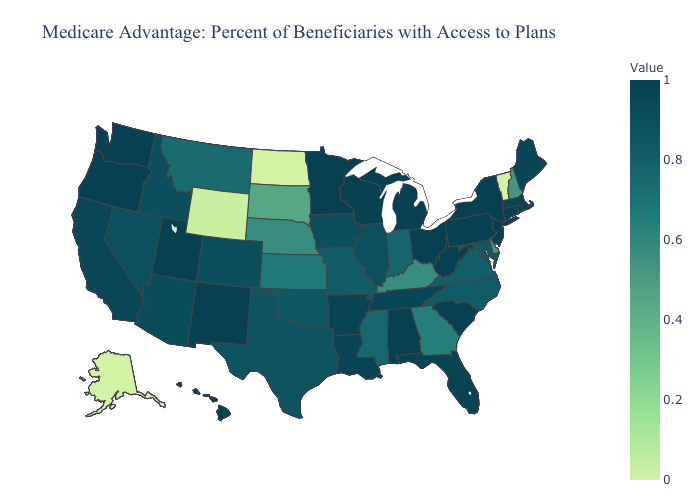Which states have the lowest value in the USA?
Give a very brief answer. Alaska, North Dakota, Vermont. Among the states that border Wisconsin , which have the lowest value?
Give a very brief answer. Illinois. Which states have the lowest value in the Northeast?
Answer briefly. Vermont. Is the legend a continuous bar?
Be succinct. Yes. Does Oregon have a lower value than Illinois?
Give a very brief answer. No. Does Maine have the lowest value in the Northeast?
Answer briefly. No. 